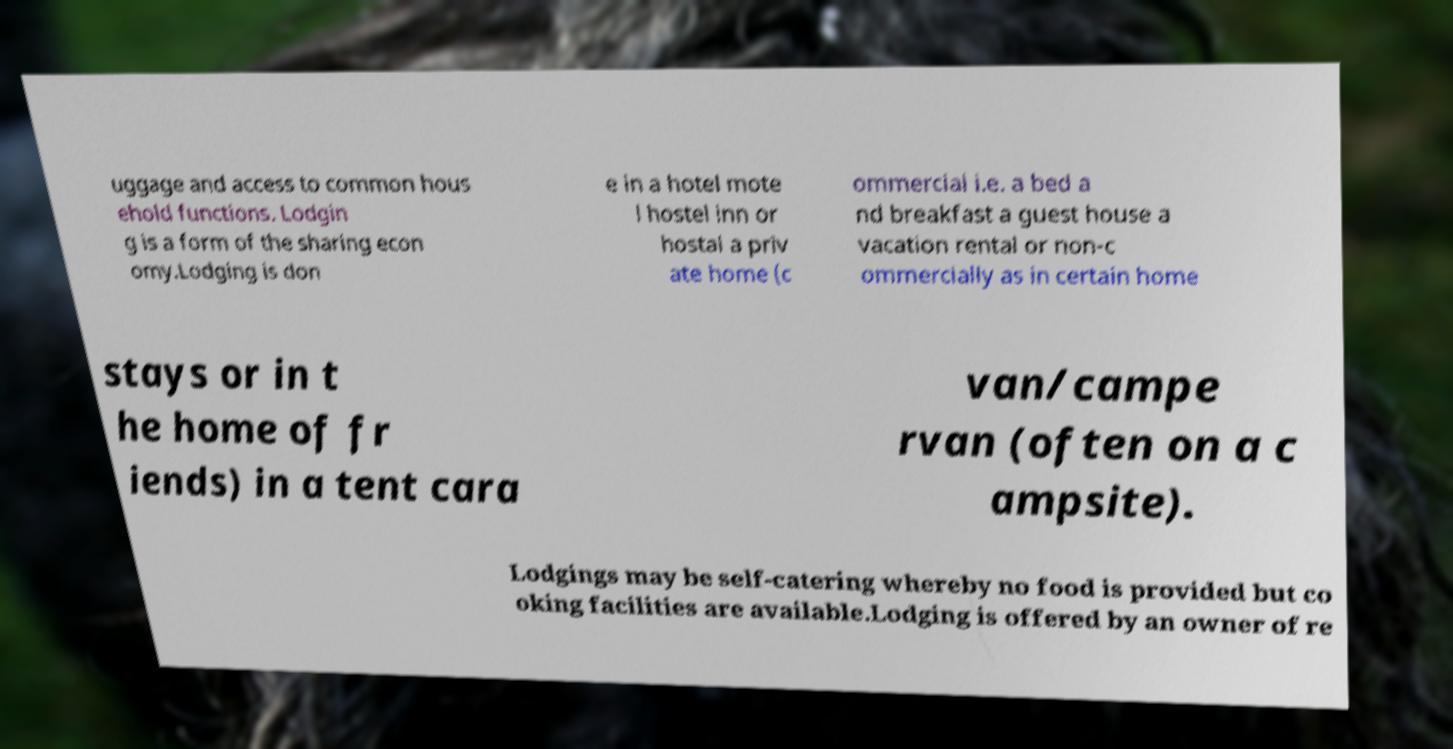Can you accurately transcribe the text from the provided image for me? uggage and access to common hous ehold functions. Lodgin g is a form of the sharing econ omy.Lodging is don e in a hotel mote l hostel inn or hostal a priv ate home (c ommercial i.e. a bed a nd breakfast a guest house a vacation rental or non-c ommercially as in certain home stays or in t he home of fr iends) in a tent cara van/campe rvan (often on a c ampsite). Lodgings may be self-catering whereby no food is provided but co oking facilities are available.Lodging is offered by an owner of re 